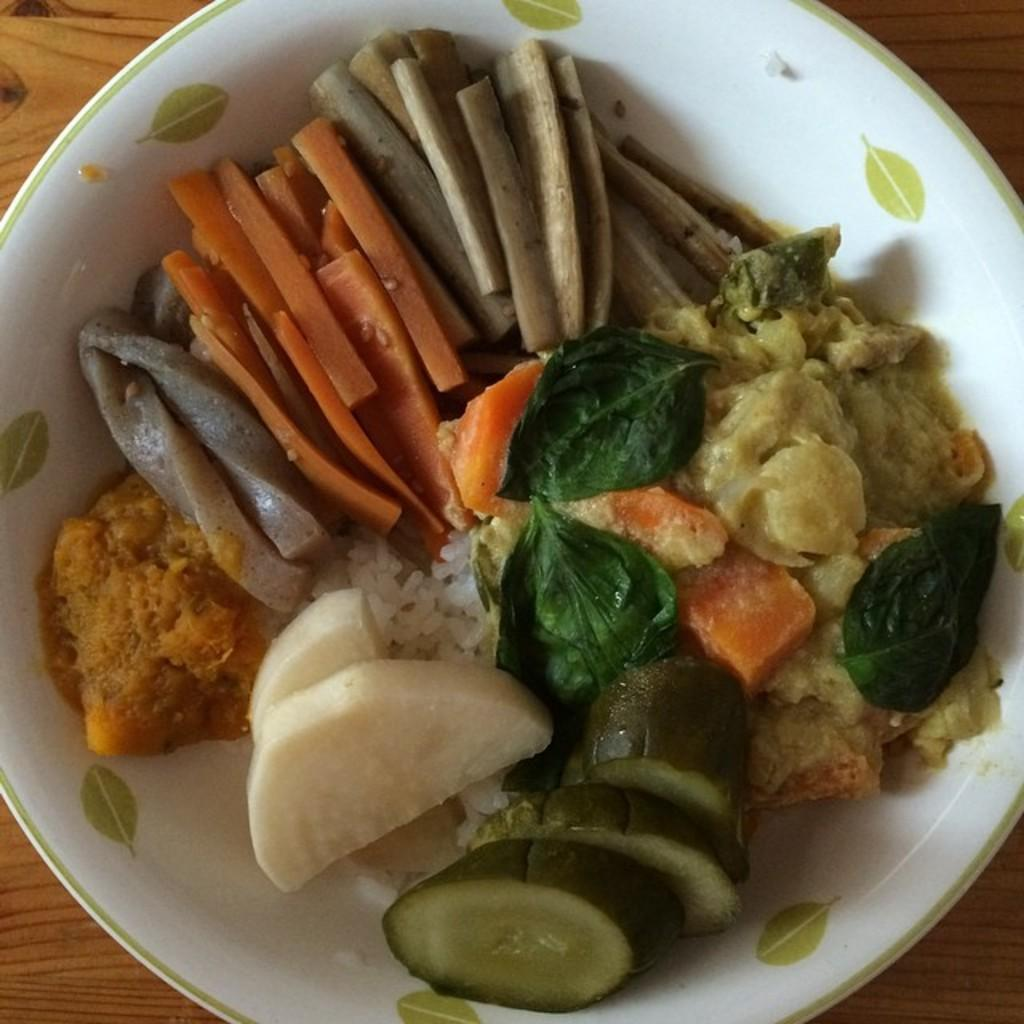What types of items can be seen in the image? There are food items in the image. What is the color of the plate on which the food items are placed? The plate is white in color. What advice does the parent give to the child in the image? There is no parent or child present in the image, as it only features food items on a white plate. 